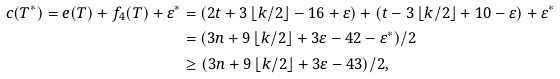<formula> <loc_0><loc_0><loc_500><loc_500>c ( T ^ { * } ) = e ( T ) + f _ { 4 } ( T ) + \varepsilon ^ { * } & = ( 2 t + 3 \left \lfloor { k } / { 2 } \right \rfloor - 1 6 + \varepsilon ) + ( t - 3 \left \lfloor { k } / { 2 } \right \rfloor + 1 0 - \varepsilon ) + \varepsilon ^ { * } \\ & = ( 3 n + 9 \left \lfloor { k } / { 2 } \right \rfloor + 3 \varepsilon - 4 2 - \varepsilon ^ { * } ) / { 2 } \\ & \geq ( 3 n + 9 \left \lfloor { k } / { 2 } \right \rfloor + 3 \varepsilon - 4 3 ) / { 2 } ,</formula> 